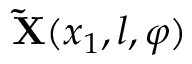<formula> <loc_0><loc_0><loc_500><loc_500>{ \tilde { X } } ( x _ { 1 } , l , \varphi )</formula> 